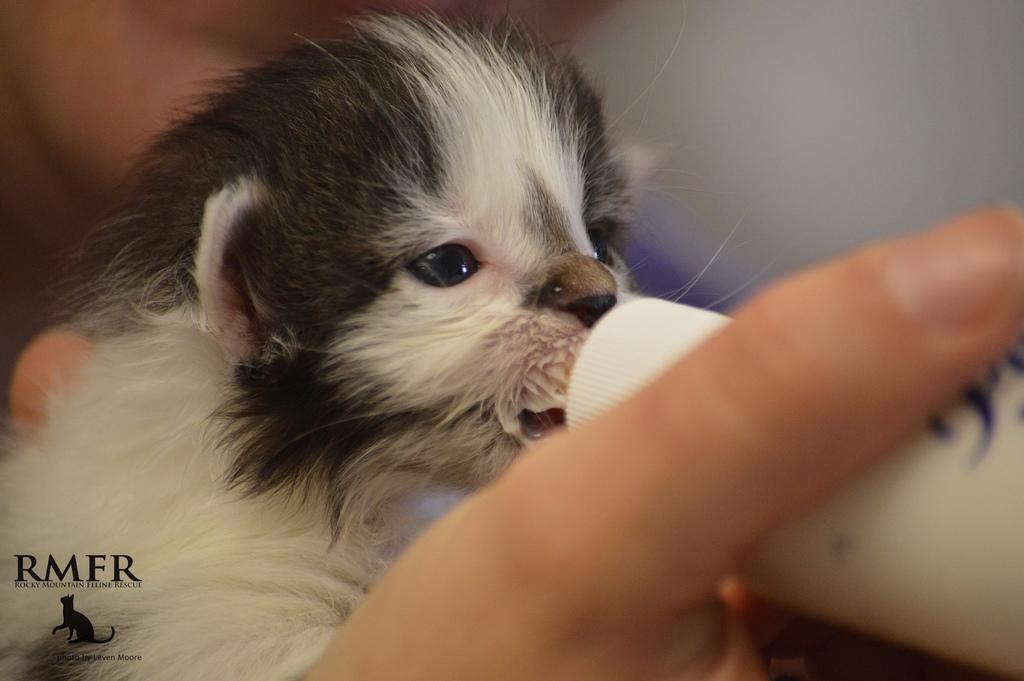Can you describe this image briefly? On the bottom left, there is a watermark. On the left side, there is an animal. On the right side, there is a hand of a person holding a white color bottle. And the background is blurred. 